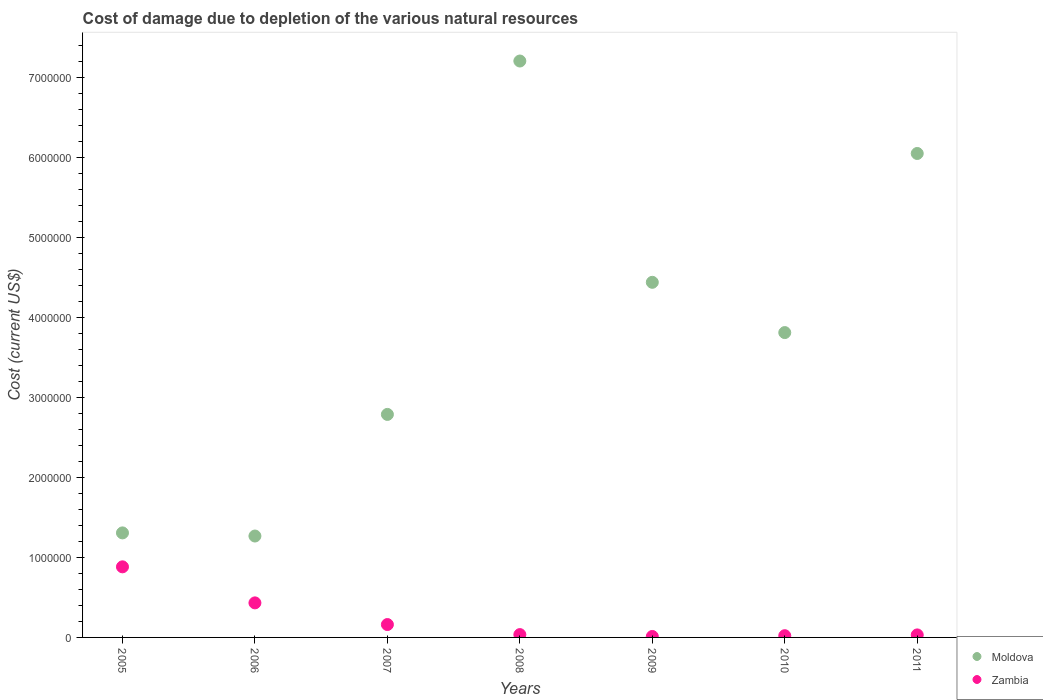What is the cost of damage caused due to the depletion of various natural resources in Zambia in 2007?
Your answer should be compact. 1.61e+05. Across all years, what is the maximum cost of damage caused due to the depletion of various natural resources in Zambia?
Provide a succinct answer. 8.82e+05. Across all years, what is the minimum cost of damage caused due to the depletion of various natural resources in Zambia?
Ensure brevity in your answer.  1.19e+04. What is the total cost of damage caused due to the depletion of various natural resources in Moldova in the graph?
Your response must be concise. 2.69e+07. What is the difference between the cost of damage caused due to the depletion of various natural resources in Moldova in 2010 and that in 2011?
Give a very brief answer. -2.24e+06. What is the difference between the cost of damage caused due to the depletion of various natural resources in Moldova in 2006 and the cost of damage caused due to the depletion of various natural resources in Zambia in 2011?
Provide a succinct answer. 1.24e+06. What is the average cost of damage caused due to the depletion of various natural resources in Moldova per year?
Keep it short and to the point. 3.84e+06. In the year 2010, what is the difference between the cost of damage caused due to the depletion of various natural resources in Zambia and cost of damage caused due to the depletion of various natural resources in Moldova?
Ensure brevity in your answer.  -3.79e+06. In how many years, is the cost of damage caused due to the depletion of various natural resources in Moldova greater than 2000000 US$?
Your answer should be very brief. 5. What is the ratio of the cost of damage caused due to the depletion of various natural resources in Zambia in 2008 to that in 2010?
Offer a very short reply. 1.64. Is the difference between the cost of damage caused due to the depletion of various natural resources in Zambia in 2008 and 2011 greater than the difference between the cost of damage caused due to the depletion of various natural resources in Moldova in 2008 and 2011?
Your answer should be very brief. No. What is the difference between the highest and the second highest cost of damage caused due to the depletion of various natural resources in Moldova?
Ensure brevity in your answer.  1.16e+06. What is the difference between the highest and the lowest cost of damage caused due to the depletion of various natural resources in Zambia?
Your response must be concise. 8.70e+05. In how many years, is the cost of damage caused due to the depletion of various natural resources in Moldova greater than the average cost of damage caused due to the depletion of various natural resources in Moldova taken over all years?
Offer a very short reply. 3. Is the sum of the cost of damage caused due to the depletion of various natural resources in Zambia in 2006 and 2010 greater than the maximum cost of damage caused due to the depletion of various natural resources in Moldova across all years?
Your response must be concise. No. Does the cost of damage caused due to the depletion of various natural resources in Zambia monotonically increase over the years?
Your response must be concise. No. Are the values on the major ticks of Y-axis written in scientific E-notation?
Provide a succinct answer. No. Does the graph contain any zero values?
Offer a terse response. No. Where does the legend appear in the graph?
Make the answer very short. Bottom right. How many legend labels are there?
Offer a very short reply. 2. How are the legend labels stacked?
Offer a very short reply. Vertical. What is the title of the graph?
Your answer should be very brief. Cost of damage due to depletion of the various natural resources. Does "Rwanda" appear as one of the legend labels in the graph?
Keep it short and to the point. No. What is the label or title of the Y-axis?
Offer a terse response. Cost (current US$). What is the Cost (current US$) in Moldova in 2005?
Provide a succinct answer. 1.31e+06. What is the Cost (current US$) of Zambia in 2005?
Offer a terse response. 8.82e+05. What is the Cost (current US$) of Moldova in 2006?
Offer a very short reply. 1.27e+06. What is the Cost (current US$) in Zambia in 2006?
Provide a short and direct response. 4.32e+05. What is the Cost (current US$) in Moldova in 2007?
Your response must be concise. 2.79e+06. What is the Cost (current US$) in Zambia in 2007?
Provide a short and direct response. 1.61e+05. What is the Cost (current US$) of Moldova in 2008?
Your answer should be compact. 7.20e+06. What is the Cost (current US$) of Zambia in 2008?
Ensure brevity in your answer.  3.53e+04. What is the Cost (current US$) in Moldova in 2009?
Provide a succinct answer. 4.44e+06. What is the Cost (current US$) of Zambia in 2009?
Offer a terse response. 1.19e+04. What is the Cost (current US$) of Moldova in 2010?
Keep it short and to the point. 3.81e+06. What is the Cost (current US$) in Zambia in 2010?
Offer a terse response. 2.16e+04. What is the Cost (current US$) of Moldova in 2011?
Keep it short and to the point. 6.05e+06. What is the Cost (current US$) in Zambia in 2011?
Make the answer very short. 3.14e+04. Across all years, what is the maximum Cost (current US$) in Moldova?
Ensure brevity in your answer.  7.20e+06. Across all years, what is the maximum Cost (current US$) of Zambia?
Ensure brevity in your answer.  8.82e+05. Across all years, what is the minimum Cost (current US$) in Moldova?
Ensure brevity in your answer.  1.27e+06. Across all years, what is the minimum Cost (current US$) of Zambia?
Provide a succinct answer. 1.19e+04. What is the total Cost (current US$) in Moldova in the graph?
Offer a terse response. 2.69e+07. What is the total Cost (current US$) in Zambia in the graph?
Give a very brief answer. 1.58e+06. What is the difference between the Cost (current US$) of Moldova in 2005 and that in 2006?
Make the answer very short. 3.91e+04. What is the difference between the Cost (current US$) of Zambia in 2005 and that in 2006?
Provide a succinct answer. 4.50e+05. What is the difference between the Cost (current US$) of Moldova in 2005 and that in 2007?
Offer a terse response. -1.48e+06. What is the difference between the Cost (current US$) in Zambia in 2005 and that in 2007?
Keep it short and to the point. 7.21e+05. What is the difference between the Cost (current US$) of Moldova in 2005 and that in 2008?
Provide a short and direct response. -5.90e+06. What is the difference between the Cost (current US$) of Zambia in 2005 and that in 2008?
Ensure brevity in your answer.  8.47e+05. What is the difference between the Cost (current US$) of Moldova in 2005 and that in 2009?
Your response must be concise. -3.13e+06. What is the difference between the Cost (current US$) in Zambia in 2005 and that in 2009?
Your answer should be compact. 8.70e+05. What is the difference between the Cost (current US$) of Moldova in 2005 and that in 2010?
Keep it short and to the point. -2.50e+06. What is the difference between the Cost (current US$) in Zambia in 2005 and that in 2010?
Make the answer very short. 8.61e+05. What is the difference between the Cost (current US$) of Moldova in 2005 and that in 2011?
Give a very brief answer. -4.74e+06. What is the difference between the Cost (current US$) of Zambia in 2005 and that in 2011?
Offer a terse response. 8.51e+05. What is the difference between the Cost (current US$) of Moldova in 2006 and that in 2007?
Your response must be concise. -1.52e+06. What is the difference between the Cost (current US$) in Zambia in 2006 and that in 2007?
Your answer should be compact. 2.71e+05. What is the difference between the Cost (current US$) in Moldova in 2006 and that in 2008?
Offer a very short reply. -5.94e+06. What is the difference between the Cost (current US$) in Zambia in 2006 and that in 2008?
Ensure brevity in your answer.  3.96e+05. What is the difference between the Cost (current US$) in Moldova in 2006 and that in 2009?
Your answer should be compact. -3.17e+06. What is the difference between the Cost (current US$) in Zambia in 2006 and that in 2009?
Keep it short and to the point. 4.20e+05. What is the difference between the Cost (current US$) of Moldova in 2006 and that in 2010?
Provide a short and direct response. -2.54e+06. What is the difference between the Cost (current US$) in Zambia in 2006 and that in 2010?
Ensure brevity in your answer.  4.10e+05. What is the difference between the Cost (current US$) in Moldova in 2006 and that in 2011?
Your answer should be very brief. -4.78e+06. What is the difference between the Cost (current US$) in Zambia in 2006 and that in 2011?
Provide a short and direct response. 4.00e+05. What is the difference between the Cost (current US$) of Moldova in 2007 and that in 2008?
Ensure brevity in your answer.  -4.42e+06. What is the difference between the Cost (current US$) of Zambia in 2007 and that in 2008?
Your response must be concise. 1.26e+05. What is the difference between the Cost (current US$) of Moldova in 2007 and that in 2009?
Your response must be concise. -1.65e+06. What is the difference between the Cost (current US$) of Zambia in 2007 and that in 2009?
Your response must be concise. 1.49e+05. What is the difference between the Cost (current US$) of Moldova in 2007 and that in 2010?
Make the answer very short. -1.02e+06. What is the difference between the Cost (current US$) of Zambia in 2007 and that in 2010?
Offer a terse response. 1.39e+05. What is the difference between the Cost (current US$) of Moldova in 2007 and that in 2011?
Ensure brevity in your answer.  -3.26e+06. What is the difference between the Cost (current US$) of Zambia in 2007 and that in 2011?
Provide a succinct answer. 1.30e+05. What is the difference between the Cost (current US$) in Moldova in 2008 and that in 2009?
Your response must be concise. 2.77e+06. What is the difference between the Cost (current US$) of Zambia in 2008 and that in 2009?
Your answer should be very brief. 2.34e+04. What is the difference between the Cost (current US$) of Moldova in 2008 and that in 2010?
Offer a very short reply. 3.39e+06. What is the difference between the Cost (current US$) in Zambia in 2008 and that in 2010?
Provide a short and direct response. 1.38e+04. What is the difference between the Cost (current US$) of Moldova in 2008 and that in 2011?
Provide a succinct answer. 1.16e+06. What is the difference between the Cost (current US$) of Zambia in 2008 and that in 2011?
Keep it short and to the point. 3896.36. What is the difference between the Cost (current US$) of Moldova in 2009 and that in 2010?
Provide a succinct answer. 6.28e+05. What is the difference between the Cost (current US$) of Zambia in 2009 and that in 2010?
Offer a very short reply. -9682.72. What is the difference between the Cost (current US$) in Moldova in 2009 and that in 2011?
Provide a short and direct response. -1.61e+06. What is the difference between the Cost (current US$) in Zambia in 2009 and that in 2011?
Your answer should be very brief. -1.95e+04. What is the difference between the Cost (current US$) in Moldova in 2010 and that in 2011?
Offer a very short reply. -2.24e+06. What is the difference between the Cost (current US$) in Zambia in 2010 and that in 2011?
Offer a very short reply. -9863.62. What is the difference between the Cost (current US$) in Moldova in 2005 and the Cost (current US$) in Zambia in 2006?
Ensure brevity in your answer.  8.75e+05. What is the difference between the Cost (current US$) of Moldova in 2005 and the Cost (current US$) of Zambia in 2007?
Give a very brief answer. 1.15e+06. What is the difference between the Cost (current US$) of Moldova in 2005 and the Cost (current US$) of Zambia in 2008?
Give a very brief answer. 1.27e+06. What is the difference between the Cost (current US$) in Moldova in 2005 and the Cost (current US$) in Zambia in 2009?
Provide a short and direct response. 1.29e+06. What is the difference between the Cost (current US$) in Moldova in 2005 and the Cost (current US$) in Zambia in 2010?
Provide a succinct answer. 1.28e+06. What is the difference between the Cost (current US$) in Moldova in 2005 and the Cost (current US$) in Zambia in 2011?
Provide a succinct answer. 1.27e+06. What is the difference between the Cost (current US$) in Moldova in 2006 and the Cost (current US$) in Zambia in 2007?
Your response must be concise. 1.11e+06. What is the difference between the Cost (current US$) of Moldova in 2006 and the Cost (current US$) of Zambia in 2008?
Keep it short and to the point. 1.23e+06. What is the difference between the Cost (current US$) of Moldova in 2006 and the Cost (current US$) of Zambia in 2009?
Your answer should be very brief. 1.26e+06. What is the difference between the Cost (current US$) of Moldova in 2006 and the Cost (current US$) of Zambia in 2010?
Ensure brevity in your answer.  1.25e+06. What is the difference between the Cost (current US$) of Moldova in 2006 and the Cost (current US$) of Zambia in 2011?
Your response must be concise. 1.24e+06. What is the difference between the Cost (current US$) in Moldova in 2007 and the Cost (current US$) in Zambia in 2008?
Provide a succinct answer. 2.75e+06. What is the difference between the Cost (current US$) of Moldova in 2007 and the Cost (current US$) of Zambia in 2009?
Give a very brief answer. 2.78e+06. What is the difference between the Cost (current US$) in Moldova in 2007 and the Cost (current US$) in Zambia in 2010?
Give a very brief answer. 2.77e+06. What is the difference between the Cost (current US$) in Moldova in 2007 and the Cost (current US$) in Zambia in 2011?
Make the answer very short. 2.76e+06. What is the difference between the Cost (current US$) of Moldova in 2008 and the Cost (current US$) of Zambia in 2009?
Your answer should be compact. 7.19e+06. What is the difference between the Cost (current US$) of Moldova in 2008 and the Cost (current US$) of Zambia in 2010?
Your answer should be very brief. 7.18e+06. What is the difference between the Cost (current US$) in Moldova in 2008 and the Cost (current US$) in Zambia in 2011?
Make the answer very short. 7.17e+06. What is the difference between the Cost (current US$) in Moldova in 2009 and the Cost (current US$) in Zambia in 2010?
Make the answer very short. 4.42e+06. What is the difference between the Cost (current US$) of Moldova in 2009 and the Cost (current US$) of Zambia in 2011?
Your answer should be very brief. 4.41e+06. What is the difference between the Cost (current US$) in Moldova in 2010 and the Cost (current US$) in Zambia in 2011?
Provide a short and direct response. 3.78e+06. What is the average Cost (current US$) of Moldova per year?
Give a very brief answer. 3.84e+06. What is the average Cost (current US$) of Zambia per year?
Your response must be concise. 2.25e+05. In the year 2005, what is the difference between the Cost (current US$) of Moldova and Cost (current US$) of Zambia?
Offer a very short reply. 4.24e+05. In the year 2006, what is the difference between the Cost (current US$) of Moldova and Cost (current US$) of Zambia?
Provide a succinct answer. 8.35e+05. In the year 2007, what is the difference between the Cost (current US$) in Moldova and Cost (current US$) in Zambia?
Your answer should be compact. 2.63e+06. In the year 2008, what is the difference between the Cost (current US$) in Moldova and Cost (current US$) in Zambia?
Your response must be concise. 7.17e+06. In the year 2009, what is the difference between the Cost (current US$) of Moldova and Cost (current US$) of Zambia?
Offer a very short reply. 4.43e+06. In the year 2010, what is the difference between the Cost (current US$) of Moldova and Cost (current US$) of Zambia?
Provide a succinct answer. 3.79e+06. In the year 2011, what is the difference between the Cost (current US$) of Moldova and Cost (current US$) of Zambia?
Offer a very short reply. 6.02e+06. What is the ratio of the Cost (current US$) of Moldova in 2005 to that in 2006?
Provide a short and direct response. 1.03. What is the ratio of the Cost (current US$) of Zambia in 2005 to that in 2006?
Offer a very short reply. 2.04. What is the ratio of the Cost (current US$) of Moldova in 2005 to that in 2007?
Your answer should be very brief. 0.47. What is the ratio of the Cost (current US$) in Zambia in 2005 to that in 2007?
Provide a short and direct response. 5.48. What is the ratio of the Cost (current US$) in Moldova in 2005 to that in 2008?
Your answer should be very brief. 0.18. What is the ratio of the Cost (current US$) of Zambia in 2005 to that in 2008?
Keep it short and to the point. 24.97. What is the ratio of the Cost (current US$) of Moldova in 2005 to that in 2009?
Keep it short and to the point. 0.29. What is the ratio of the Cost (current US$) of Zambia in 2005 to that in 2009?
Your answer should be compact. 74.2. What is the ratio of the Cost (current US$) in Moldova in 2005 to that in 2010?
Your answer should be very brief. 0.34. What is the ratio of the Cost (current US$) of Zambia in 2005 to that in 2010?
Your answer should be very brief. 40.9. What is the ratio of the Cost (current US$) in Moldova in 2005 to that in 2011?
Offer a very short reply. 0.22. What is the ratio of the Cost (current US$) in Zambia in 2005 to that in 2011?
Make the answer very short. 28.06. What is the ratio of the Cost (current US$) of Moldova in 2006 to that in 2007?
Make the answer very short. 0.45. What is the ratio of the Cost (current US$) of Zambia in 2006 to that in 2007?
Provide a succinct answer. 2.68. What is the ratio of the Cost (current US$) of Moldova in 2006 to that in 2008?
Offer a very short reply. 0.18. What is the ratio of the Cost (current US$) of Zambia in 2006 to that in 2008?
Give a very brief answer. 12.22. What is the ratio of the Cost (current US$) in Moldova in 2006 to that in 2009?
Your answer should be compact. 0.29. What is the ratio of the Cost (current US$) in Zambia in 2006 to that in 2009?
Offer a terse response. 36.31. What is the ratio of the Cost (current US$) in Moldova in 2006 to that in 2010?
Give a very brief answer. 0.33. What is the ratio of the Cost (current US$) in Zambia in 2006 to that in 2010?
Your answer should be very brief. 20.01. What is the ratio of the Cost (current US$) in Moldova in 2006 to that in 2011?
Ensure brevity in your answer.  0.21. What is the ratio of the Cost (current US$) of Zambia in 2006 to that in 2011?
Your answer should be compact. 13.73. What is the ratio of the Cost (current US$) in Moldova in 2007 to that in 2008?
Your answer should be compact. 0.39. What is the ratio of the Cost (current US$) of Zambia in 2007 to that in 2008?
Your response must be concise. 4.56. What is the ratio of the Cost (current US$) in Moldova in 2007 to that in 2009?
Your answer should be compact. 0.63. What is the ratio of the Cost (current US$) of Zambia in 2007 to that in 2009?
Your answer should be very brief. 13.54. What is the ratio of the Cost (current US$) in Moldova in 2007 to that in 2010?
Provide a short and direct response. 0.73. What is the ratio of the Cost (current US$) of Zambia in 2007 to that in 2010?
Offer a very short reply. 7.46. What is the ratio of the Cost (current US$) in Moldova in 2007 to that in 2011?
Your response must be concise. 0.46. What is the ratio of the Cost (current US$) of Zambia in 2007 to that in 2011?
Give a very brief answer. 5.12. What is the ratio of the Cost (current US$) of Moldova in 2008 to that in 2009?
Provide a short and direct response. 1.62. What is the ratio of the Cost (current US$) in Zambia in 2008 to that in 2009?
Offer a very short reply. 2.97. What is the ratio of the Cost (current US$) of Moldova in 2008 to that in 2010?
Your response must be concise. 1.89. What is the ratio of the Cost (current US$) of Zambia in 2008 to that in 2010?
Offer a very short reply. 1.64. What is the ratio of the Cost (current US$) of Moldova in 2008 to that in 2011?
Provide a succinct answer. 1.19. What is the ratio of the Cost (current US$) in Zambia in 2008 to that in 2011?
Your answer should be very brief. 1.12. What is the ratio of the Cost (current US$) of Moldova in 2009 to that in 2010?
Your response must be concise. 1.16. What is the ratio of the Cost (current US$) in Zambia in 2009 to that in 2010?
Make the answer very short. 0.55. What is the ratio of the Cost (current US$) of Moldova in 2009 to that in 2011?
Provide a short and direct response. 0.73. What is the ratio of the Cost (current US$) of Zambia in 2009 to that in 2011?
Ensure brevity in your answer.  0.38. What is the ratio of the Cost (current US$) of Moldova in 2010 to that in 2011?
Give a very brief answer. 0.63. What is the ratio of the Cost (current US$) of Zambia in 2010 to that in 2011?
Give a very brief answer. 0.69. What is the difference between the highest and the second highest Cost (current US$) of Moldova?
Give a very brief answer. 1.16e+06. What is the difference between the highest and the second highest Cost (current US$) of Zambia?
Ensure brevity in your answer.  4.50e+05. What is the difference between the highest and the lowest Cost (current US$) of Moldova?
Your response must be concise. 5.94e+06. What is the difference between the highest and the lowest Cost (current US$) of Zambia?
Ensure brevity in your answer.  8.70e+05. 